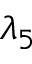Convert formula to latex. <formula><loc_0><loc_0><loc_500><loc_500>\lambda _ { 5 }</formula> 